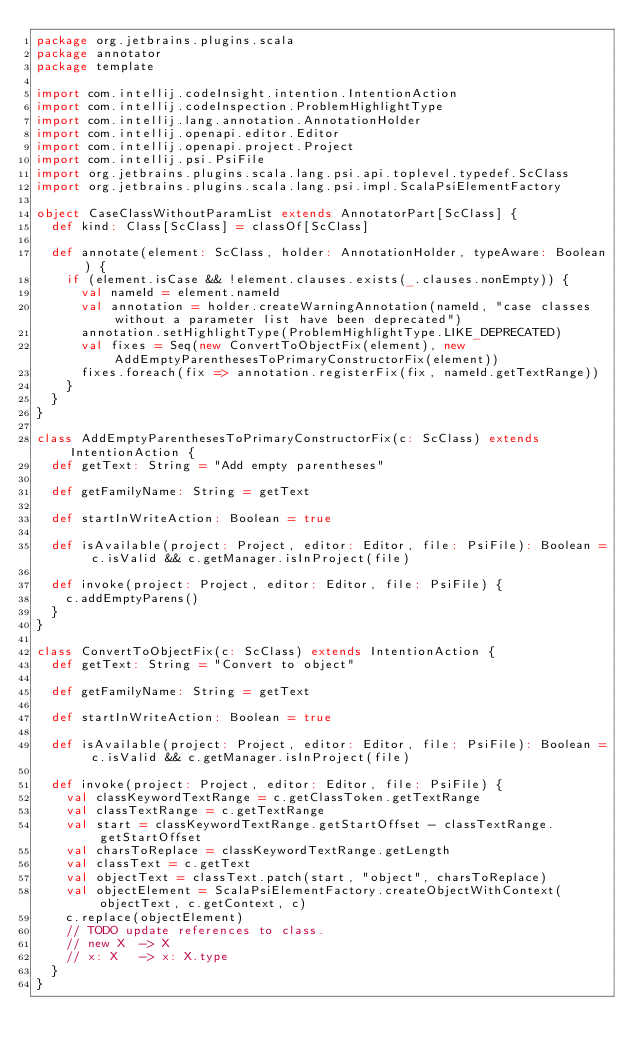<code> <loc_0><loc_0><loc_500><loc_500><_Scala_>package org.jetbrains.plugins.scala
package annotator
package template

import com.intellij.codeInsight.intention.IntentionAction
import com.intellij.codeInspection.ProblemHighlightType
import com.intellij.lang.annotation.AnnotationHolder
import com.intellij.openapi.editor.Editor
import com.intellij.openapi.project.Project
import com.intellij.psi.PsiFile
import org.jetbrains.plugins.scala.lang.psi.api.toplevel.typedef.ScClass
import org.jetbrains.plugins.scala.lang.psi.impl.ScalaPsiElementFactory

object CaseClassWithoutParamList extends AnnotatorPart[ScClass] {
  def kind: Class[ScClass] = classOf[ScClass]

  def annotate(element: ScClass, holder: AnnotationHolder, typeAware: Boolean) {
    if (element.isCase && !element.clauses.exists(_.clauses.nonEmpty)) {
      val nameId = element.nameId
      val annotation = holder.createWarningAnnotation(nameId, "case classes without a parameter list have been deprecated")
      annotation.setHighlightType(ProblemHighlightType.LIKE_DEPRECATED)
      val fixes = Seq(new ConvertToObjectFix(element), new AddEmptyParenthesesToPrimaryConstructorFix(element))
      fixes.foreach(fix => annotation.registerFix(fix, nameId.getTextRange))
    }
  }
}

class AddEmptyParenthesesToPrimaryConstructorFix(c: ScClass) extends IntentionAction {
  def getText: String = "Add empty parentheses"

  def getFamilyName: String = getText

  def startInWriteAction: Boolean = true

  def isAvailable(project: Project, editor: Editor, file: PsiFile): Boolean = c.isValid && c.getManager.isInProject(file)

  def invoke(project: Project, editor: Editor, file: PsiFile) {
    c.addEmptyParens()
  }
}

class ConvertToObjectFix(c: ScClass) extends IntentionAction {
  def getText: String = "Convert to object"

  def getFamilyName: String = getText

  def startInWriteAction: Boolean = true

  def isAvailable(project: Project, editor: Editor, file: PsiFile): Boolean = c.isValid && c.getManager.isInProject(file)

  def invoke(project: Project, editor: Editor, file: PsiFile) {
    val classKeywordTextRange = c.getClassToken.getTextRange
    val classTextRange = c.getTextRange
    val start = classKeywordTextRange.getStartOffset - classTextRange.getStartOffset
    val charsToReplace = classKeywordTextRange.getLength
    val classText = c.getText
    val objectText = classText.patch(start, "object", charsToReplace)
    val objectElement = ScalaPsiElementFactory.createObjectWithContext(objectText, c.getContext, c)
    c.replace(objectElement)
    // TODO update references to class.
    // new X  -> X
    // x: X   -> x: X.type
  }
}
</code> 